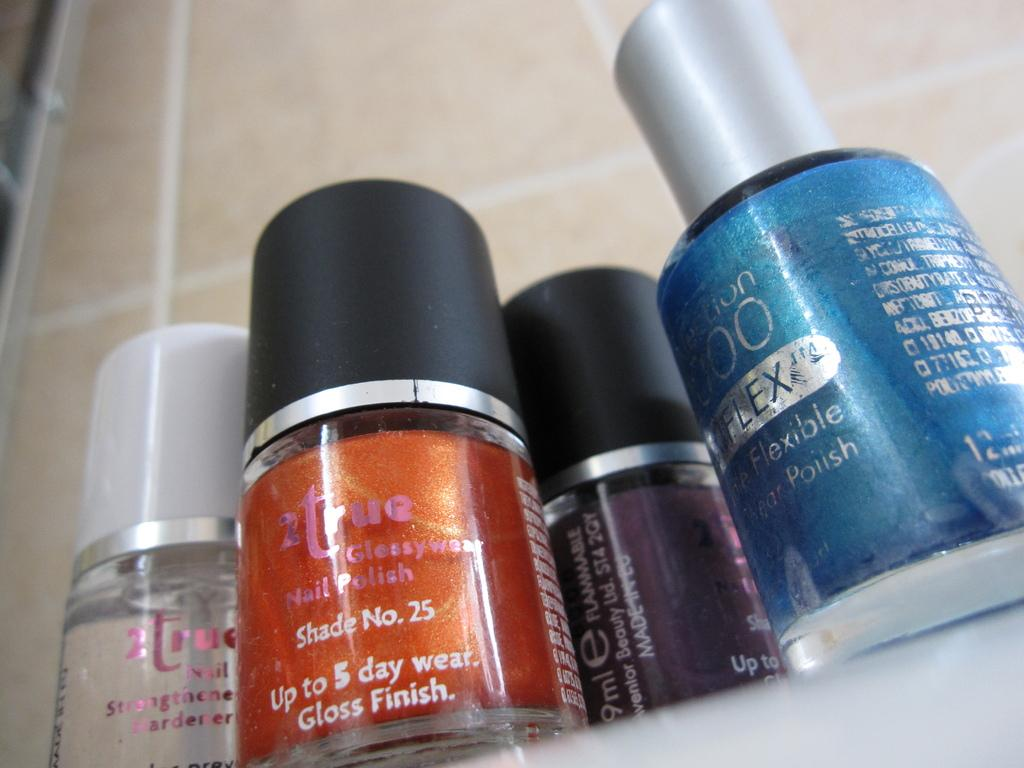<image>
Write a terse but informative summary of the picture. Four different nail polishes, including 2true Shade No. 25 are grouped together on a counter. 